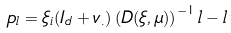<formula> <loc_0><loc_0><loc_500><loc_500>p _ { l } = \xi _ { i } ( I _ { d } + v _ { . } ) \left ( D ( \xi , \mu ) \right ) ^ { - 1 } l - l</formula> 